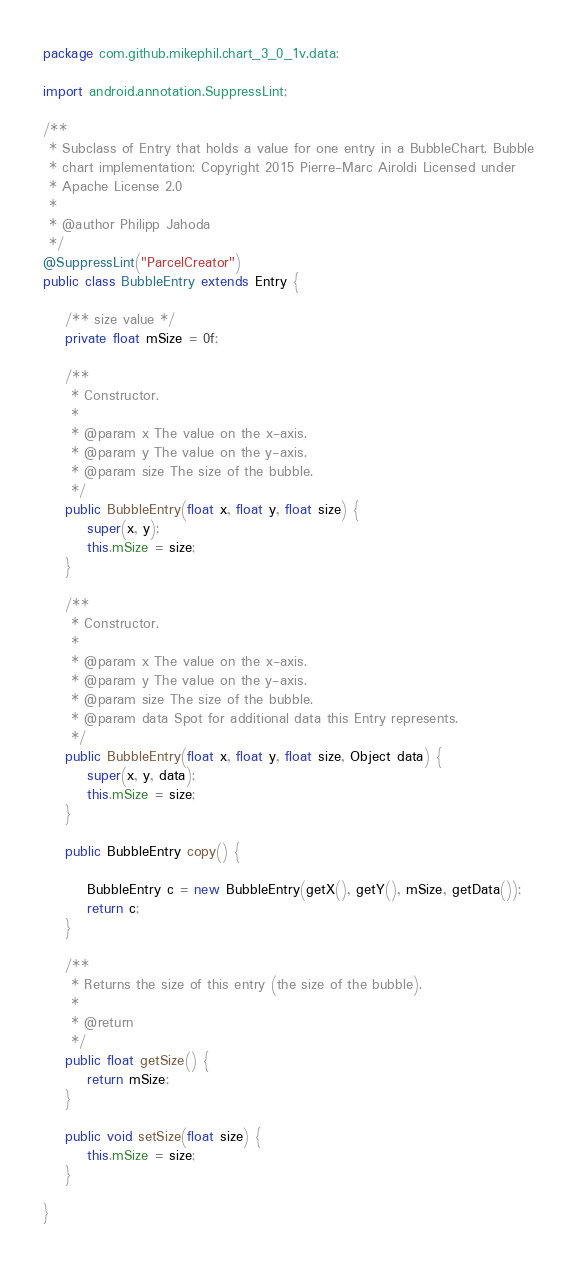<code> <loc_0><loc_0><loc_500><loc_500><_Java_>
package com.github.mikephil.chart_3_0_1v.data;

import android.annotation.SuppressLint;

/**
 * Subclass of Entry that holds a value for one entry in a BubbleChart. Bubble
 * chart implementation: Copyright 2015 Pierre-Marc Airoldi Licensed under
 * Apache License 2.0
 *
 * @author Philipp Jahoda
 */
@SuppressLint("ParcelCreator")
public class BubbleEntry extends Entry {

    /** size value */
    private float mSize = 0f;

    /**
     * Constructor.
     *
     * @param x The value on the x-axis.
     * @param y The value on the y-axis.
     * @param size The size of the bubble.
     */
    public BubbleEntry(float x, float y, float size) {
        super(x, y);
        this.mSize = size;
    }

    /**
     * Constructor.
     *
     * @param x The value on the x-axis.
     * @param y The value on the y-axis.
     * @param size The size of the bubble.
     * @param data Spot for additional data this Entry represents.
     */
    public BubbleEntry(float x, float y, float size, Object data) {
        super(x, y, data);
        this.mSize = size;
    }

    public BubbleEntry copy() {

        BubbleEntry c = new BubbleEntry(getX(), getY(), mSize, getData());
        return c;
    }

    /**
     * Returns the size of this entry (the size of the bubble).
     *
     * @return
     */
    public float getSize() {
        return mSize;
    }

    public void setSize(float size) {
        this.mSize = size;
    }

}
</code> 